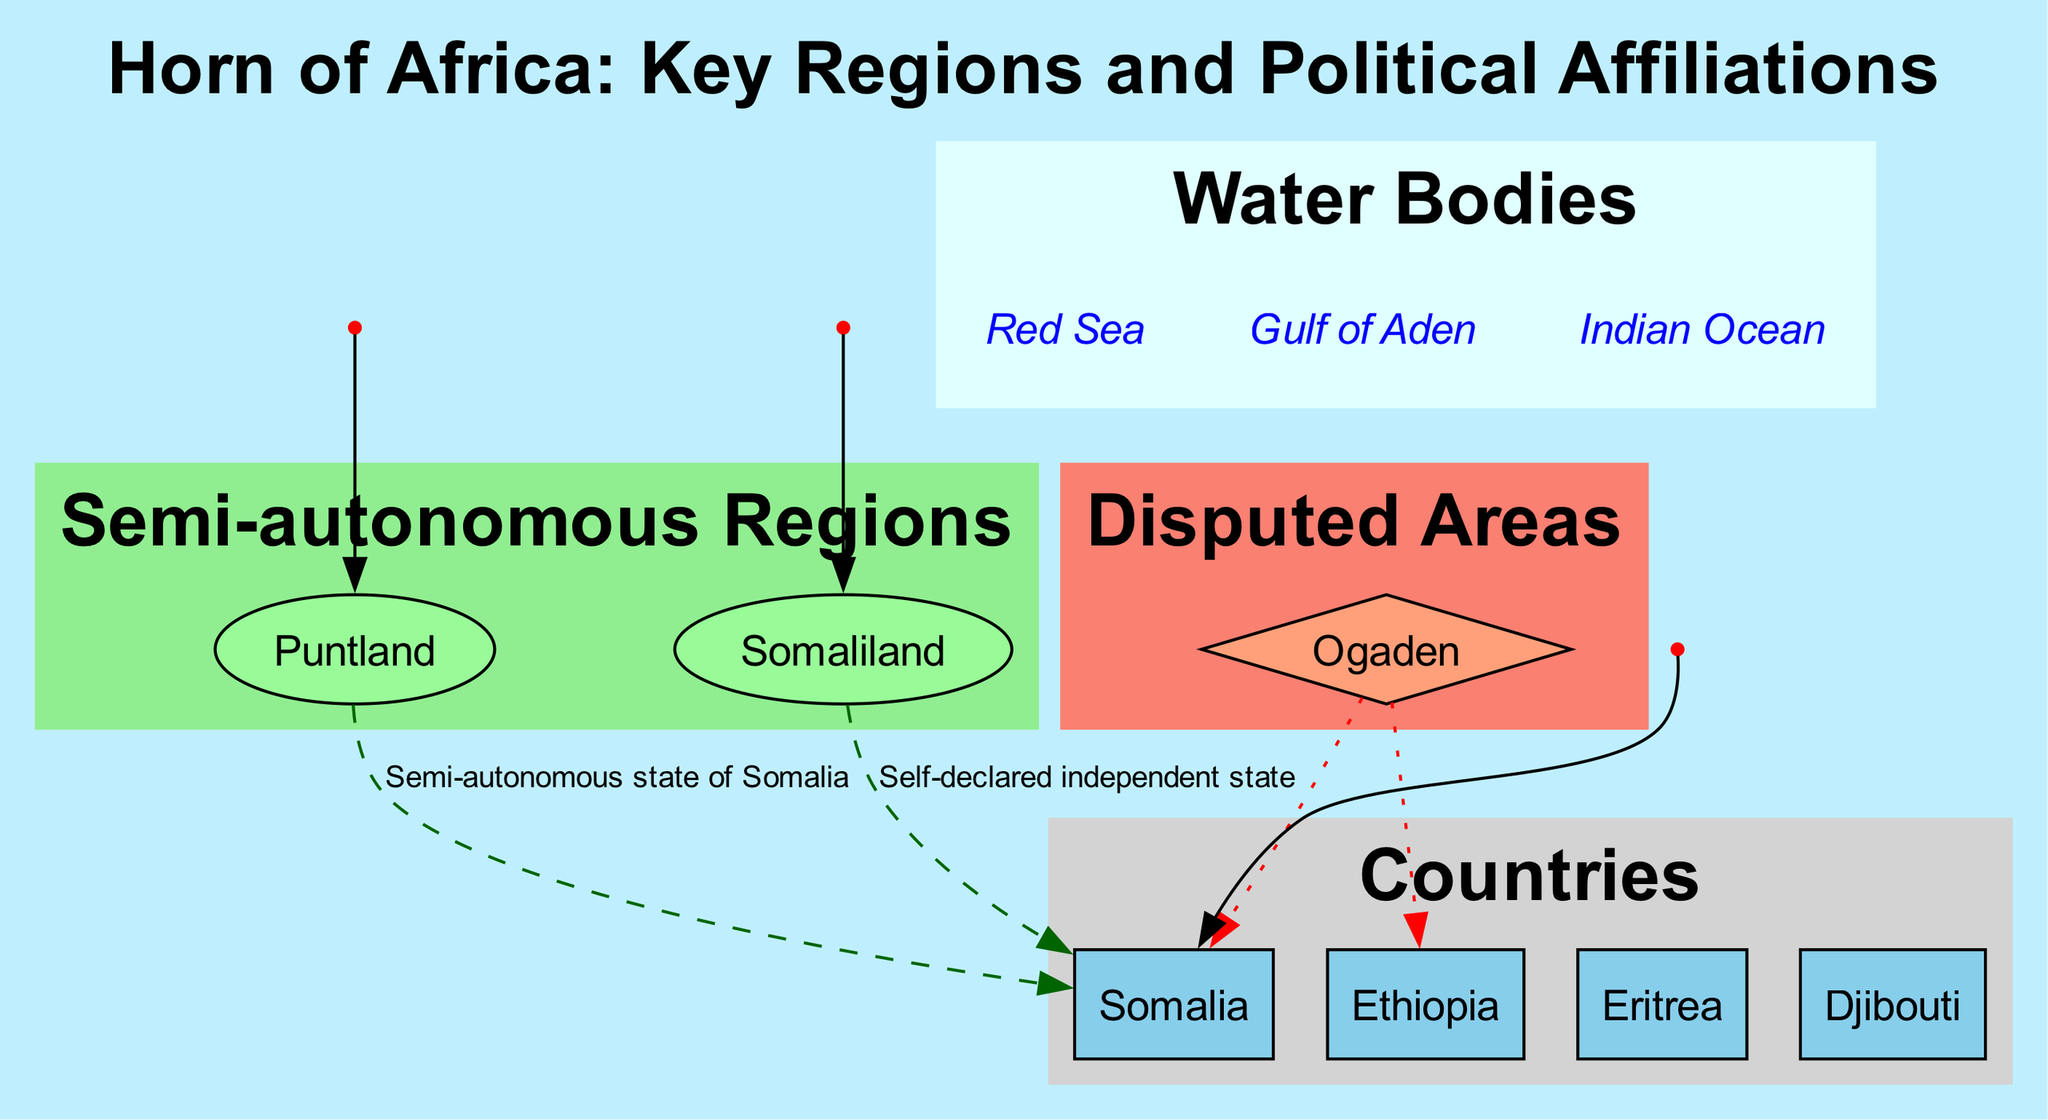What are the semi-autonomous regions highlighted in the diagram? The diagram specifically lists two semi-autonomous regions, which can be found in the "Semi-autonomous Regions" cluster. They are Puntland and Somaliland.
Answer: Puntland, Somaliland How many countries are depicted in the diagram? The diagram indicates four countries within the "Countries" cluster, which can be counted directly: Somalia, Ethiopia, Eritrea, and Djibouti.
Answer: 4 What political affiliation is shown for Puntland? The affiliation of Puntland can be identified through the dashed line connecting it to Somalia, marked as "Semi-autonomous state of Somalia."
Answer: Semi-autonomous state of Somalia Which disputed area is indicated in the diagram? The diagram highlights the Ogaden as a disputed area, shown in the "Disputed Areas" cluster, labeled with the countries that dispute it.
Answer: Ogaden How many key cities are identified in the Horn of Africa region on this map? The diagram contains three key cities represented by points and connected to either their country or region, namely Mogadishu, Garowe, and Hargeisa.
Answer: 3 What relationship do Ethiopia and Somalia have with the Ogaden? The diagram shows a dotted line between the Ogaden and both Ethiopia and Somalia, indicating that both countries claim the area, demonstrating a dispute.
Answer: Dispute Which water body is the closest to Somalia according to the diagram? The water bodies listed in the diagram include the Red Sea, Gulf of Aden, and Indian Ocean; the Gulf of Aden is closest to Somalia as it is directly adjacent.
Answer: Gulf of Aden What type of relationship does Somaliland have with Somalia? The diagram shows Somaliland as a self-declared independent state, which suggests it considers itself separate from Somalia, rather than being a semi-autonomous region.
Answer: Self-declared independent state Where is Garowe located according to the diagram? Garowe is depicted in the diagram as being part of Puntland, indicated by its connection to the Puntland region and the context of the diagram describing Puntland’s affiliation.
Answer: Puntland 